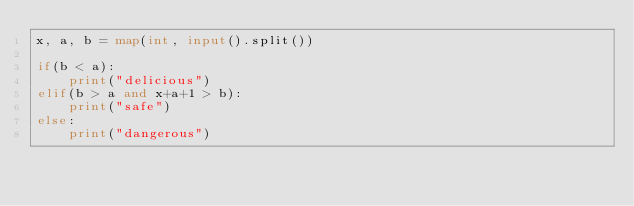<code> <loc_0><loc_0><loc_500><loc_500><_Python_>x, a, b = map(int, input().split())

if(b < a):
    print("delicious")
elif(b > a and x+a+1 > b):
    print("safe")
else:
    print("dangerous")</code> 